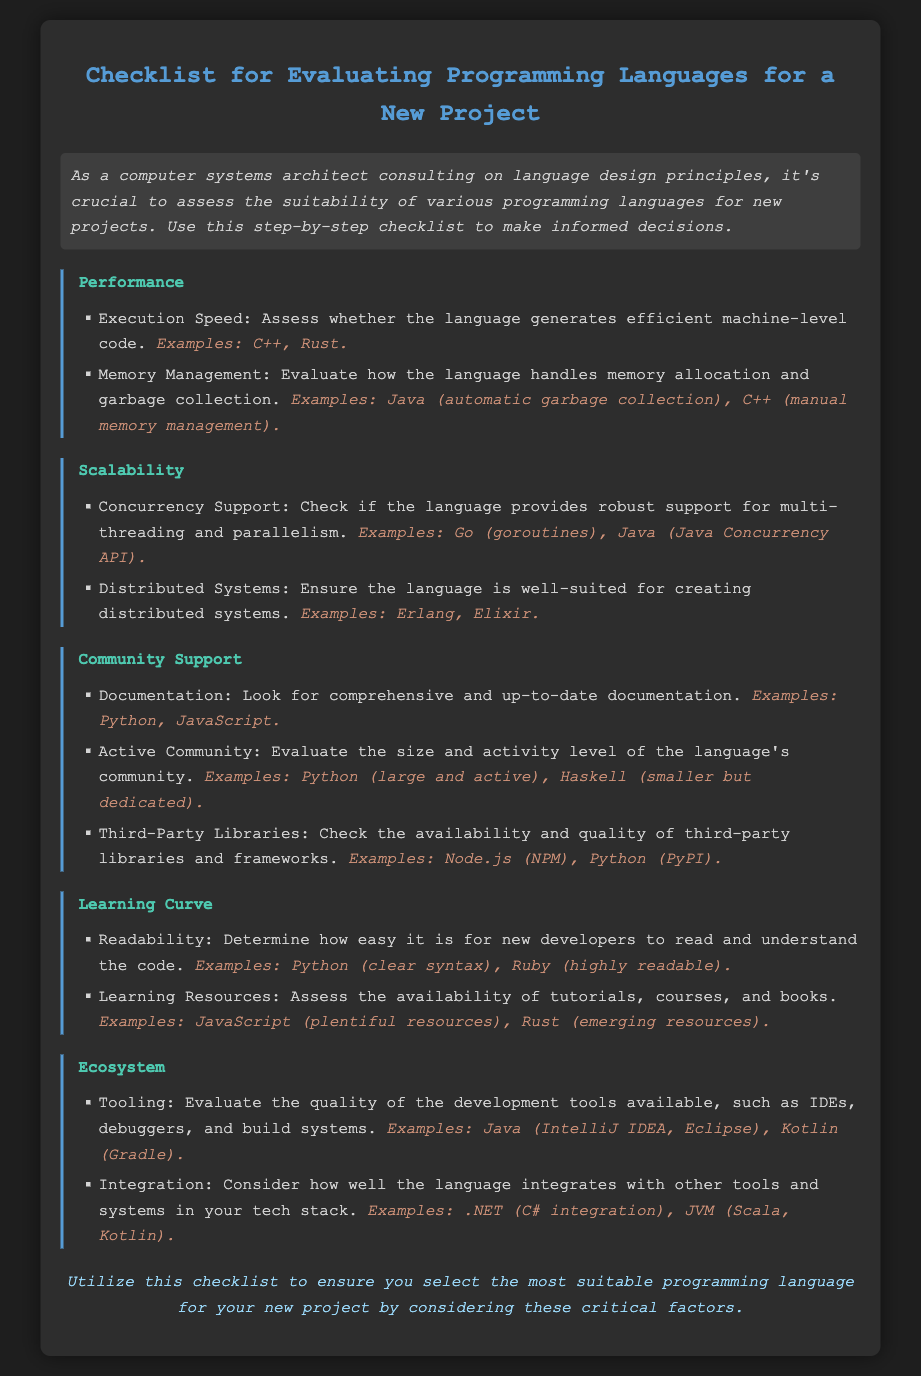What are the two main aspects of performance to evaluate? The document lists 'Execution Speed' and 'Memory Management' as the two main aspects of performance to evaluate.
Answer: Execution Speed, Memory Management What is an example of a language that supports concurrency? The checklist mentions Go and Java as examples of languages that provide robust support for concurrency.
Answer: Go, Java Which programming language is associated with automatic garbage collection? The document specifies Java as the language that uses automatic garbage collection for memory management.
Answer: Java What should you assess regarding learning resources? The document states that you should assess the availability of tutorials, courses, and books regarding learning resources.
Answer: Availability of tutorials, courses, and books Which category includes the evaluation of IDEs and debuggers? The document categorizes the evaluation of IDEs and debuggers under 'Tooling'.
Answer: Tooling What examples are given for languages with comprehensive documentation? The checklist mentions Python and JavaScript as examples that have comprehensive and up-to-date documentation.
Answer: Python, JavaScript How does the document classify the need for integration in programming languages? The checklist includes integration as part of the 'Ecosystem' evaluation category.
Answer: Ecosystem Which language is mentioned as having a clear syntax? The document lists Python as an example of a language with clear syntax that contributes to readability.
Answer: Python What is the purpose of this checklist? The document states that the checklist is utilized to select the most suitable programming language for new projects.
Answer: Select the most suitable programming language 